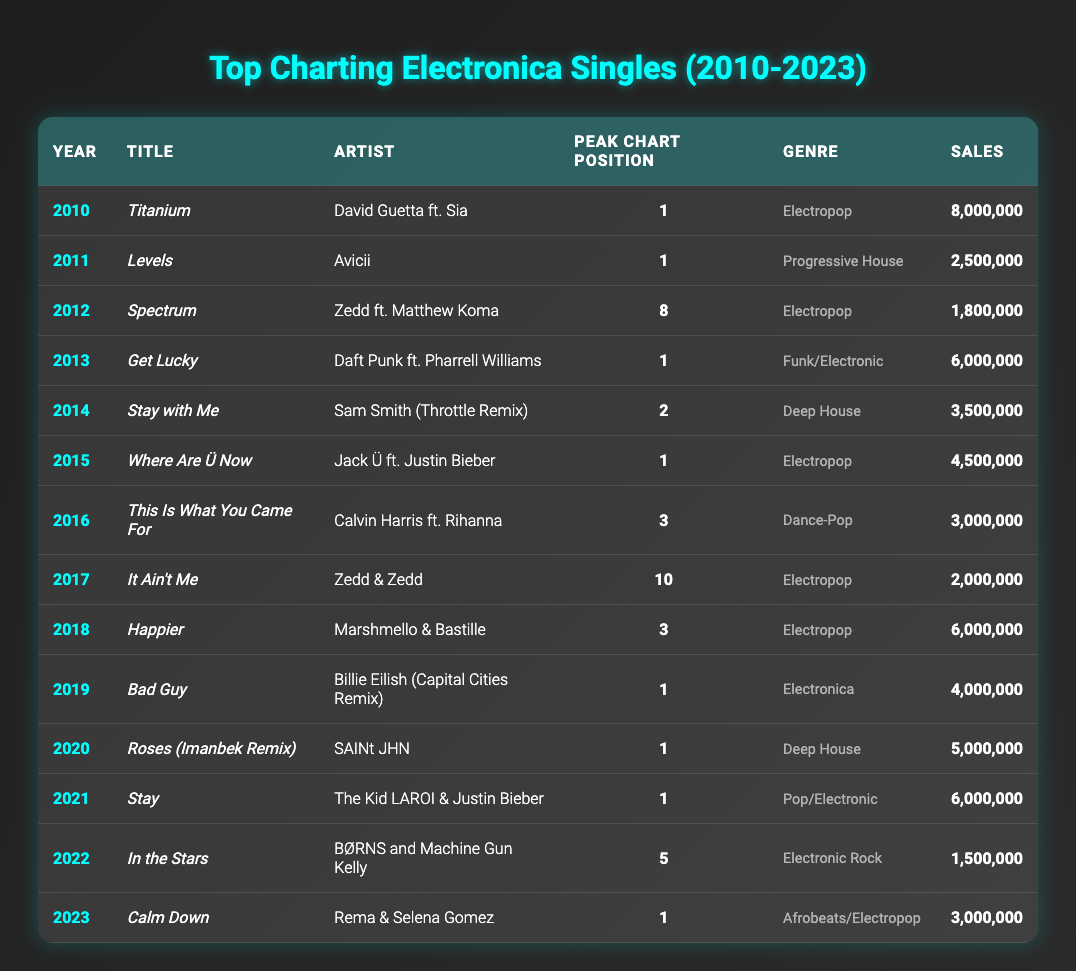What is the title of the single that peaked at number 1 in 2013? The year 2013 has the single "Get Lucky" by Daft Punk ft. Pharrell Williams listed under the Peak Chart Position column with a value of 1.
Answer: Get Lucky How many singles peaked at number 1 during the years 2010 to 2023? By counting the rows for years where the Peak Chart Position is 1, we find that there are 8 singles: "Titanium," "Levels," "Get Lucky," "Where Are Ü Now," "Roses (Imanbek Remix)," "Stay," "Bad Guy," and "Calm Down."
Answer: 8 What is the total sales figure for singles categorized as Electropop? The Electropop singles listed are "Titanium" with 8,000,000, "Spectrum" with 1,800,000, "Where Are Ü Now" with 4,500,000, "It Ain't Me" with 2,000,000, "Happier" with 6,000,000, and "Stay" (Pop/Electronic) with 6,000,000. The total sales sum is 8,000,000 + 1,800,000 + 4,500,000 + 2,000,000 + 6,000,000 + 6,000,000 = 28,300,000.
Answer: 28,300,000 Did any singles appear more than once in the top charting list? Reviewing the table, no artist repeats a song title in more than one year, confirming that there are no singles listed more than once.
Answer: No Which year had the highest sales for a single in the table? The highest sales are for "Titanium" from 2010, which sold 8,000,000 copies. To find it, compare the Sales column across all years, confirming that no other single has higher sales figures.
Answer: 2010 What is the average sales figure for all songs from the years 2013 to 2022? The sales figures from 2013 to 2022 are 6,000,000 (Get Lucky), 3,500,000 (Stay with Me), 4,500,000 (Where Are Ü Now), 3,000,000 (This Is What You Came For), 2,000,000 (It Ain't Me), 6,000,000 (Happier), 4,000,000 (Bad Guy), 5,000,000 (Roses), 6,000,000 (Stay), and 1,500,000 (In the Stars). The total is 42,500,000, with 10 entries. The average is 42,500,000 / 10 = 4,250,000.
Answer: 4,250,000 Which artist had the highest single sales in 2021? The single "Stay" by The Kid LAROI & Justin Bieber had the highest sales in 2021, at 6,000,000. This is evident upon reviewing the sales column for that year.
Answer: The Kid LAROI & Justin Bieber How many songs have a peak chart position of 3 or higher? The songs with peak positions of 3 or higher are “Titanium” (1), “Levels” (1), “Get Lucky” (1), “Where Are Ü Now” (1), “Happier” (3), “Roses (Imanbek Remix)” (1), “Stay” (1), “Bad Guy” (1), and "This Is What You Came For" (3). Counting these gives a total of 7 songs.
Answer: 7 